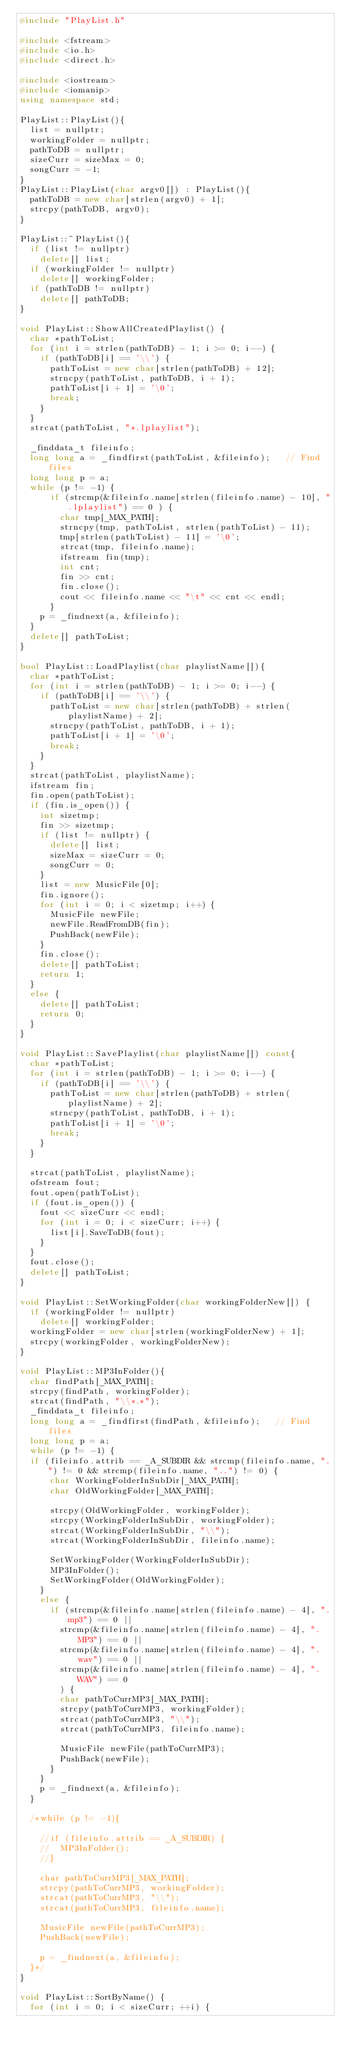<code> <loc_0><loc_0><loc_500><loc_500><_C++_>#include "PlayList.h"

#include <fstream>
#include <io.h>
#include <direct.h>

#include <iostream>
#include <iomanip>
using namespace std;

PlayList::PlayList(){
	list = nullptr;
	workingFolder = nullptr;
	pathToDB = nullptr;
	sizeCurr = sizeMax = 0;
	songCurr = -1;
}
PlayList::PlayList(char argv0[]) : PlayList(){
	pathToDB = new char[strlen(argv0) + 1];
	strcpy(pathToDB, argv0);
}

PlayList::~PlayList(){
	if (list != nullptr)
		delete[] list;
	if (workingFolder != nullptr)
		delete[] workingFolder;
	if (pathToDB != nullptr)
		delete[] pathToDB;
}

void PlayList::ShowAllCreatedPlaylist() {
	char *pathToList;
	for (int i = strlen(pathToDB) - 1; i >= 0; i--) {
		if (pathToDB[i] == '\\') {
			pathToList = new char[strlen(pathToDB) + 12];
			strncpy(pathToList, pathToDB, i + 1);
			pathToList[i + 1] = '\0';
			break;
		}
	}
	strcat(pathToList, "*.lplaylist");

	_finddata_t fileinfo;
	long long a = _findfirst(pathToList, &fileinfo);   // Find files
	long long p = a;
	while (p != -1) {
			if (strcmp(&fileinfo.name[strlen(fileinfo.name) - 10], ".lplaylist") == 0 ) {
				char tmp[_MAX_PATH];
				strncpy(tmp, pathToList, strlen(pathToList) - 11);
				tmp[strlen(pathToList) - 11] = '\0';
				strcat(tmp, fileinfo.name);
				ifstream fin(tmp);
				int cnt;
				fin >> cnt;
				fin.close();
				cout << fileinfo.name << "\t" << cnt << endl;
			}
		p = _findnext(a, &fileinfo);
	}
	delete[] pathToList;
}

bool PlayList::LoadPlaylist(char playlistName[]){
	char *pathToList;
	for (int i = strlen(pathToDB) - 1; i >= 0; i--) {
		if (pathToDB[i] == '\\') {
			pathToList = new char[strlen(pathToDB) + strlen(playlistName) + 2];
			strncpy(pathToList, pathToDB, i + 1);
			pathToList[i + 1] = '\0';
			break;
		}
	}
	strcat(pathToList, playlistName);
	ifstream fin;
	fin.open(pathToList);
	if (fin.is_open()) {
		int sizetmp;
		fin >> sizetmp;
		if (list != nullptr) {
			delete[] list;
			sizeMax = sizeCurr = 0;
			songCurr = 0;
		}
		list = new MusicFile[0];
		fin.ignore();
		for (int i = 0; i < sizetmp; i++) {
			MusicFile newFile;
			newFile.ReadFromDB(fin);
			PushBack(newFile);
		}
		fin.close();
		delete[] pathToList;
		return 1;
	}
	else {
		delete[] pathToList;
		return 0;
	}
}

void PlayList::SavePlaylist(char playlistName[]) const{
	char *pathToList;
	for (int i = strlen(pathToDB) - 1; i >= 0; i--) {
		if (pathToDB[i] == '\\') {
			pathToList = new char[strlen(pathToDB) + strlen(playlistName) + 2];
			strncpy(pathToList, pathToDB, i + 1);
			pathToList[i + 1] = '\0';
			break;
		}
	}

	strcat(pathToList, playlistName);
	ofstream fout;
	fout.open(pathToList);
	if (fout.is_open()) {
		fout << sizeCurr << endl;
		for (int i = 0; i < sizeCurr; i++) {
			list[i].SaveToDB(fout);
		}
	}
	fout.close();
	delete[] pathToList;
}

void PlayList::SetWorkingFolder(char workingFolderNew[]) {
	if (workingFolder != nullptr)
		delete[] workingFolder;
	workingFolder = new char[strlen(workingFolderNew) + 1];
	strcpy(workingFolder, workingFolderNew);
}

void PlayList::MP3InFolder(){
	char findPath[_MAX_PATH];
	strcpy(findPath, workingFolder);
	strcat(findPath, "\\*.*");
	_finddata_t fileinfo;
	long long a = _findfirst(findPath, &fileinfo);   // Find files
	long long p = a;
	while (p != -1) {
	if (fileinfo.attrib == _A_SUBDIR && strcmp(fileinfo.name, ".") != 0 && strcmp(fileinfo.name, "..") != 0) {
			char WorkingFolderInSubDir[_MAX_PATH];
			char OldWorkingFolder[_MAX_PATH];

			strcpy(OldWorkingFolder, workingFolder);
			strcpy(WorkingFolderInSubDir, workingFolder);
			strcat(WorkingFolderInSubDir, "\\");
			strcat(WorkingFolderInSubDir, fileinfo.name);

			SetWorkingFolder(WorkingFolderInSubDir);
			MP3InFolder();
			SetWorkingFolder(OldWorkingFolder);
		}
		else {
			if (strcmp(&fileinfo.name[strlen(fileinfo.name) - 4], ".mp3") == 0 ||
				strcmp(&fileinfo.name[strlen(fileinfo.name) - 4], ".MP3") == 0 ||
				strcmp(&fileinfo.name[strlen(fileinfo.name) - 4], ".wav") == 0 ||
				strcmp(&fileinfo.name[strlen(fileinfo.name) - 4], ".WAV") == 0
				) {
				char pathToCurrMP3[_MAX_PATH];
				strcpy(pathToCurrMP3, workingFolder);
				strcat(pathToCurrMP3, "\\");
				strcat(pathToCurrMP3, fileinfo.name);

				MusicFile newFile(pathToCurrMP3);
				PushBack(newFile);
			}
		}
		p = _findnext(a, &fileinfo);
	}

	/*while (p != -1){

		//if (fileinfo.attrib == _A_SUBDIR) {
		//	MP3InFolder();
		//}

		char pathToCurrMP3[_MAX_PATH];
		strcpy(pathToCurrMP3, workingFolder);
		strcat(pathToCurrMP3, "\\");
		strcat(pathToCurrMP3, fileinfo.name);

		MusicFile newFile(pathToCurrMP3);
		PushBack(newFile);

		p = _findnext(a, &fileinfo);
	}*/
}

void PlayList::SortByName() {
	for (int i = 0; i < sizeCurr; ++i) {</code> 